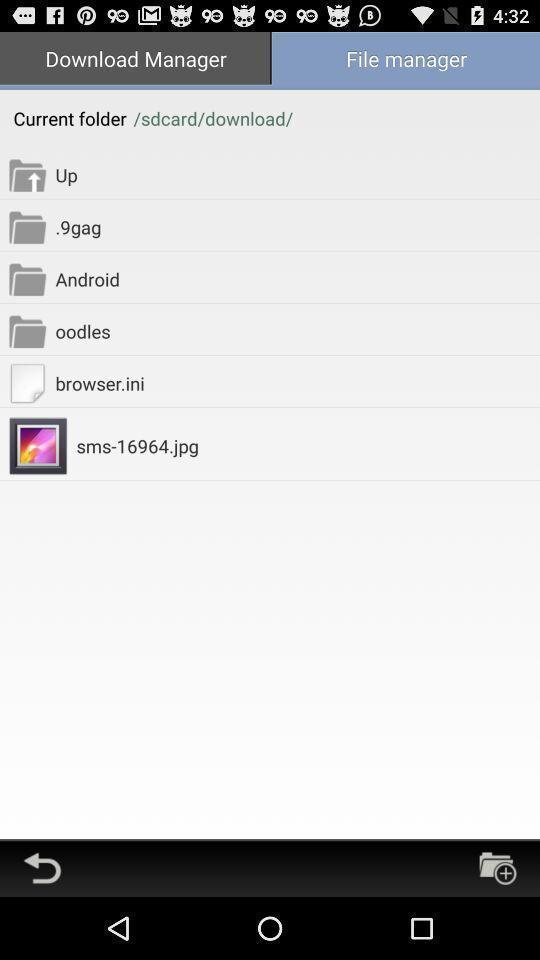What details can you identify in this image? Page showing different options under download manager. 